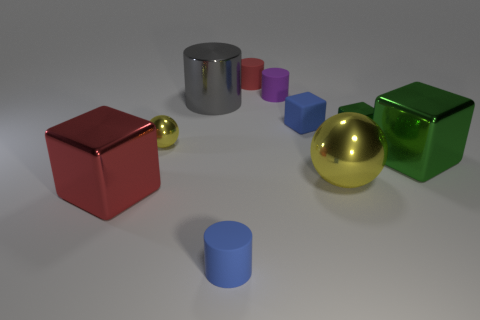What material is the thing that is the same color as the tiny metal sphere?
Your response must be concise. Metal. Are there any other things that have the same material as the big green object?
Ensure brevity in your answer.  Yes. There is a tiny purple thing; what shape is it?
Make the answer very short. Cylinder. There is a yellow thing that is the same size as the metal cylinder; what is its shape?
Keep it short and to the point. Sphere. Is there any other thing that is the same color as the large ball?
Your answer should be compact. Yes. What size is the blue cube that is made of the same material as the small red cylinder?
Offer a terse response. Small. There is a purple thing; does it have the same shape as the red object that is right of the big gray thing?
Offer a terse response. Yes. What size is the rubber cube?
Offer a terse response. Small. Is the number of purple things that are left of the red rubber thing less than the number of big yellow metallic spheres?
Give a very brief answer. Yes. How many red shiny blocks have the same size as the blue rubber block?
Your answer should be compact. 0. 